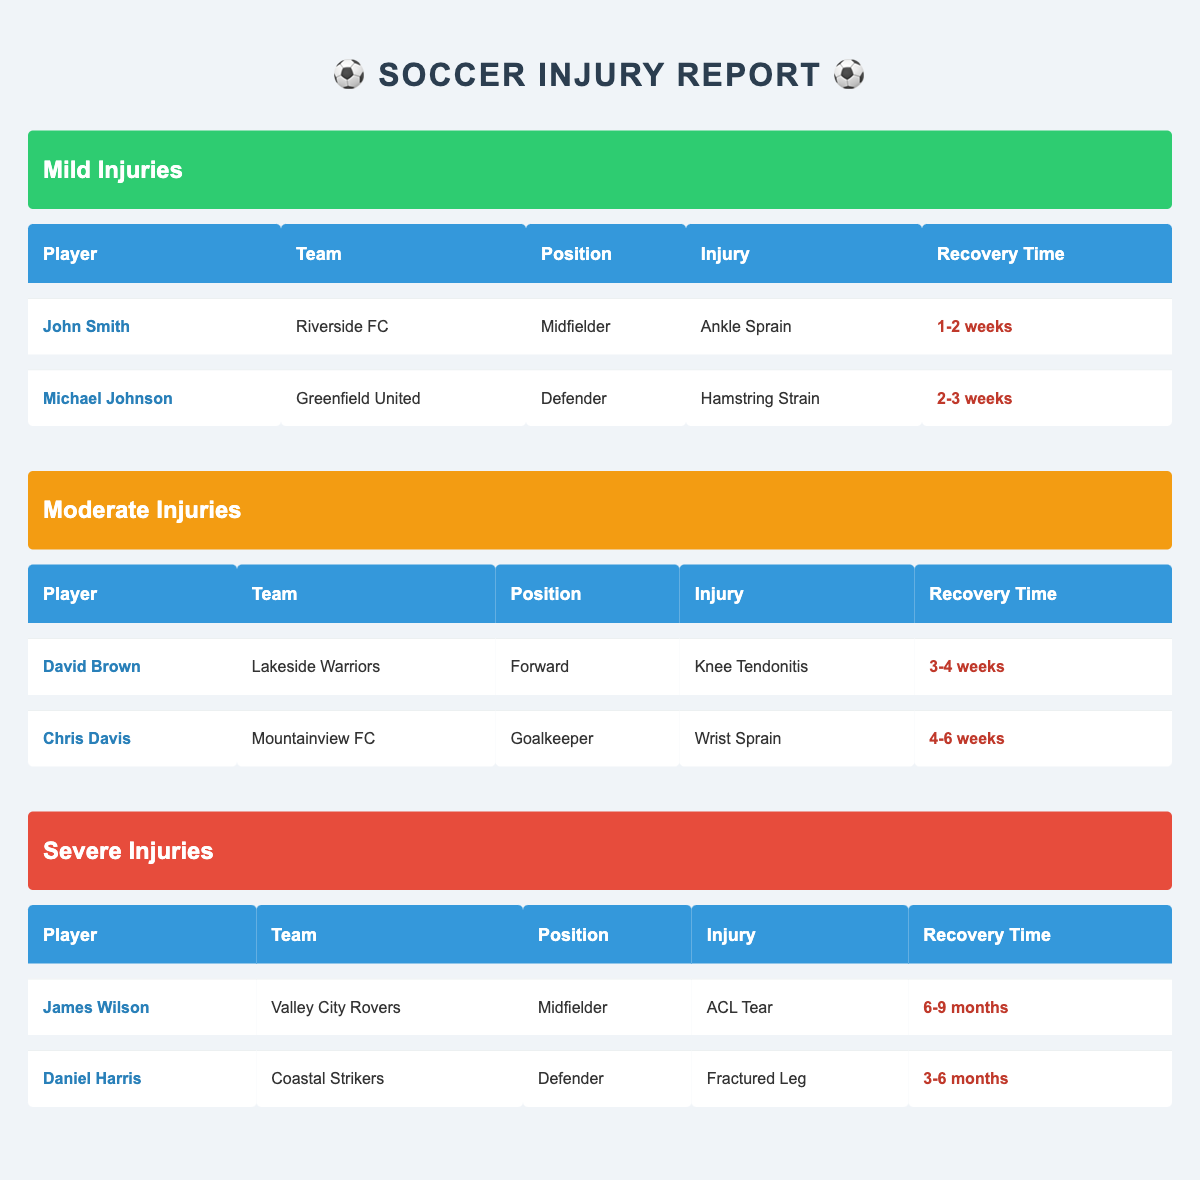What's the recovery time for John Smith? Referring to the mild injuries section, John Smith's injury is listed as an Ankle Sprain and his recovery time is noted as 1-2 weeks.
Answer: 1-2 weeks How many players have moderate injuries? In the moderate severity section, there are two players listed: David Brown and Chris Davis. Therefore, the number of players with moderate injuries is 2.
Answer: 2 Is Daniel Harris a midfielder? Checking the severe injuries section, Daniel Harris is categorized as a Defender, not a Midfielder. Therefore, the statement is false.
Answer: No What injury does Michael Johnson have? In the mild injuries section, Michael Johnson's injury is listed as a Hamstring Strain.
Answer: Hamstring Strain Which player has the longest recovery time? Evaluating the severe injuries, both James Wilson and Daniel Harris have the longest recovery times of 6-9 months and 3-6 months, respectively. Since 6 months is longer than 3 months, James Wilson has the longest recovery time.
Answer: James Wilson How many players are affected by severe injuries? In the severe injuries section, there are two players listed: James Wilson and Daniel Harris. Therefore, the number of players affected by severe injuries is 2.
Answer: 2 What is the average recovery time for mild injuries? For mild injuries, the recovery times are 1-2 weeks (John Smith) and 2-3 weeks (Michael Johnson). To calculate the average, we convert the ranges: (1.5 weeks + 2.5 weeks) / 2 = 2 weeks, so the average recovery time is 2 weeks.
Answer: 2 weeks Is Chris Davis's team the same as James Wilson's team? Chris Davis plays for Mountainview FC while James Wilson plays for Valley City Rovers. Since the teams are different, the statement is false.
Answer: No How many players have ankle injuries? In the mild injuries section, John Smith has an Ankle Sprain. Therefore, there is 1 player with an ankle injury.
Answer: 1 